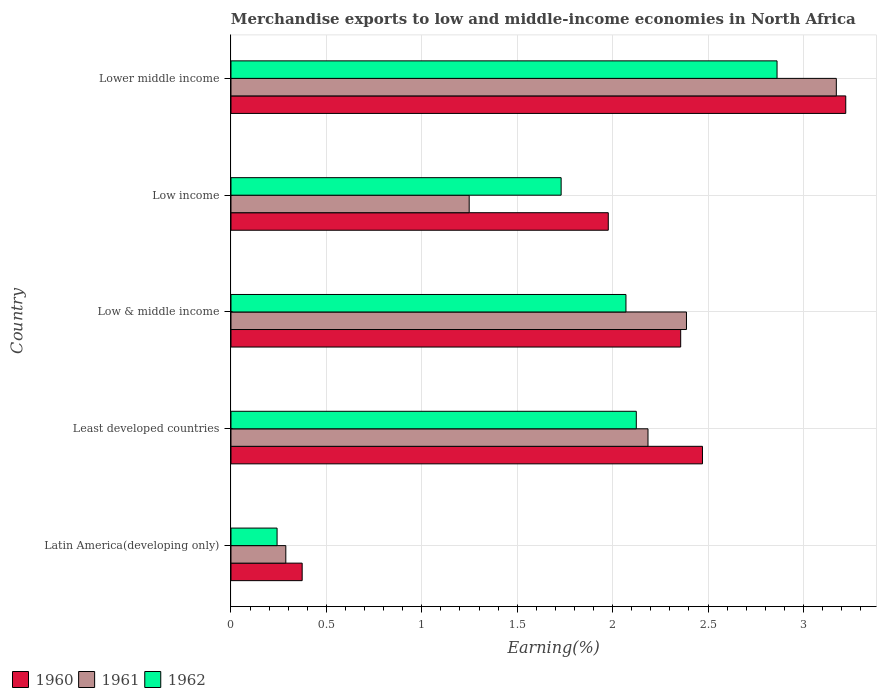Are the number of bars per tick equal to the number of legend labels?
Offer a terse response. Yes. Are the number of bars on each tick of the Y-axis equal?
Offer a terse response. Yes. How many bars are there on the 3rd tick from the top?
Give a very brief answer. 3. What is the label of the 4th group of bars from the top?
Ensure brevity in your answer.  Least developed countries. What is the percentage of amount earned from merchandise exports in 1960 in Low income?
Provide a succinct answer. 1.98. Across all countries, what is the maximum percentage of amount earned from merchandise exports in 1961?
Offer a very short reply. 3.17. Across all countries, what is the minimum percentage of amount earned from merchandise exports in 1962?
Provide a short and direct response. 0.24. In which country was the percentage of amount earned from merchandise exports in 1960 maximum?
Your answer should be compact. Lower middle income. In which country was the percentage of amount earned from merchandise exports in 1962 minimum?
Offer a terse response. Latin America(developing only). What is the total percentage of amount earned from merchandise exports in 1961 in the graph?
Provide a succinct answer. 9.28. What is the difference between the percentage of amount earned from merchandise exports in 1962 in Least developed countries and that in Lower middle income?
Offer a very short reply. -0.74. What is the difference between the percentage of amount earned from merchandise exports in 1962 in Latin America(developing only) and the percentage of amount earned from merchandise exports in 1960 in Low & middle income?
Give a very brief answer. -2.12. What is the average percentage of amount earned from merchandise exports in 1960 per country?
Ensure brevity in your answer.  2.08. What is the difference between the percentage of amount earned from merchandise exports in 1962 and percentage of amount earned from merchandise exports in 1961 in Latin America(developing only)?
Make the answer very short. -0.05. What is the ratio of the percentage of amount earned from merchandise exports in 1961 in Low & middle income to that in Low income?
Your answer should be compact. 1.91. Is the percentage of amount earned from merchandise exports in 1960 in Latin America(developing only) less than that in Low income?
Your answer should be very brief. Yes. What is the difference between the highest and the second highest percentage of amount earned from merchandise exports in 1960?
Offer a very short reply. 0.75. What is the difference between the highest and the lowest percentage of amount earned from merchandise exports in 1960?
Your answer should be compact. 2.85. In how many countries, is the percentage of amount earned from merchandise exports in 1962 greater than the average percentage of amount earned from merchandise exports in 1962 taken over all countries?
Give a very brief answer. 3. Is the sum of the percentage of amount earned from merchandise exports in 1960 in Low & middle income and Low income greater than the maximum percentage of amount earned from merchandise exports in 1962 across all countries?
Your answer should be very brief. Yes. What does the 1st bar from the top in Least developed countries represents?
Offer a very short reply. 1962. Is it the case that in every country, the sum of the percentage of amount earned from merchandise exports in 1960 and percentage of amount earned from merchandise exports in 1961 is greater than the percentage of amount earned from merchandise exports in 1962?
Make the answer very short. Yes. What is the difference between two consecutive major ticks on the X-axis?
Keep it short and to the point. 0.5. Are the values on the major ticks of X-axis written in scientific E-notation?
Provide a succinct answer. No. Does the graph contain grids?
Your answer should be compact. Yes. What is the title of the graph?
Give a very brief answer. Merchandise exports to low and middle-income economies in North Africa. What is the label or title of the X-axis?
Provide a succinct answer. Earning(%). What is the label or title of the Y-axis?
Offer a terse response. Country. What is the Earning(%) in 1960 in Latin America(developing only)?
Your response must be concise. 0.37. What is the Earning(%) in 1961 in Latin America(developing only)?
Your response must be concise. 0.29. What is the Earning(%) of 1962 in Latin America(developing only)?
Your response must be concise. 0.24. What is the Earning(%) of 1960 in Least developed countries?
Keep it short and to the point. 2.47. What is the Earning(%) in 1961 in Least developed countries?
Offer a terse response. 2.19. What is the Earning(%) of 1962 in Least developed countries?
Your response must be concise. 2.12. What is the Earning(%) of 1960 in Low & middle income?
Keep it short and to the point. 2.36. What is the Earning(%) in 1961 in Low & middle income?
Your answer should be very brief. 2.39. What is the Earning(%) of 1962 in Low & middle income?
Your response must be concise. 2.07. What is the Earning(%) of 1960 in Low income?
Your answer should be very brief. 1.98. What is the Earning(%) of 1961 in Low income?
Provide a succinct answer. 1.25. What is the Earning(%) of 1962 in Low income?
Provide a short and direct response. 1.73. What is the Earning(%) in 1960 in Lower middle income?
Your response must be concise. 3.22. What is the Earning(%) in 1961 in Lower middle income?
Provide a short and direct response. 3.17. What is the Earning(%) of 1962 in Lower middle income?
Make the answer very short. 2.86. Across all countries, what is the maximum Earning(%) in 1960?
Offer a terse response. 3.22. Across all countries, what is the maximum Earning(%) of 1961?
Make the answer very short. 3.17. Across all countries, what is the maximum Earning(%) in 1962?
Offer a very short reply. 2.86. Across all countries, what is the minimum Earning(%) of 1960?
Provide a succinct answer. 0.37. Across all countries, what is the minimum Earning(%) of 1961?
Ensure brevity in your answer.  0.29. Across all countries, what is the minimum Earning(%) in 1962?
Make the answer very short. 0.24. What is the total Earning(%) in 1960 in the graph?
Provide a succinct answer. 10.4. What is the total Earning(%) of 1961 in the graph?
Your response must be concise. 9.28. What is the total Earning(%) of 1962 in the graph?
Your response must be concise. 9.03. What is the difference between the Earning(%) of 1960 in Latin America(developing only) and that in Least developed countries?
Your response must be concise. -2.1. What is the difference between the Earning(%) in 1961 in Latin America(developing only) and that in Least developed countries?
Offer a very short reply. -1.9. What is the difference between the Earning(%) in 1962 in Latin America(developing only) and that in Least developed countries?
Your response must be concise. -1.88. What is the difference between the Earning(%) in 1960 in Latin America(developing only) and that in Low & middle income?
Make the answer very short. -1.98. What is the difference between the Earning(%) of 1961 in Latin America(developing only) and that in Low & middle income?
Make the answer very short. -2.1. What is the difference between the Earning(%) of 1962 in Latin America(developing only) and that in Low & middle income?
Give a very brief answer. -1.83. What is the difference between the Earning(%) of 1960 in Latin America(developing only) and that in Low income?
Offer a terse response. -1.6. What is the difference between the Earning(%) in 1961 in Latin America(developing only) and that in Low income?
Ensure brevity in your answer.  -0.96. What is the difference between the Earning(%) of 1962 in Latin America(developing only) and that in Low income?
Offer a very short reply. -1.49. What is the difference between the Earning(%) of 1960 in Latin America(developing only) and that in Lower middle income?
Offer a terse response. -2.85. What is the difference between the Earning(%) in 1961 in Latin America(developing only) and that in Lower middle income?
Ensure brevity in your answer.  -2.88. What is the difference between the Earning(%) of 1962 in Latin America(developing only) and that in Lower middle income?
Your answer should be compact. -2.62. What is the difference between the Earning(%) of 1960 in Least developed countries and that in Low & middle income?
Your answer should be compact. 0.11. What is the difference between the Earning(%) of 1961 in Least developed countries and that in Low & middle income?
Make the answer very short. -0.2. What is the difference between the Earning(%) in 1962 in Least developed countries and that in Low & middle income?
Provide a succinct answer. 0.05. What is the difference between the Earning(%) of 1960 in Least developed countries and that in Low income?
Your response must be concise. 0.49. What is the difference between the Earning(%) of 1961 in Least developed countries and that in Low income?
Keep it short and to the point. 0.94. What is the difference between the Earning(%) of 1962 in Least developed countries and that in Low income?
Keep it short and to the point. 0.39. What is the difference between the Earning(%) in 1960 in Least developed countries and that in Lower middle income?
Your answer should be compact. -0.75. What is the difference between the Earning(%) in 1961 in Least developed countries and that in Lower middle income?
Offer a terse response. -0.99. What is the difference between the Earning(%) in 1962 in Least developed countries and that in Lower middle income?
Offer a terse response. -0.74. What is the difference between the Earning(%) of 1960 in Low & middle income and that in Low income?
Provide a short and direct response. 0.38. What is the difference between the Earning(%) in 1961 in Low & middle income and that in Low income?
Make the answer very short. 1.14. What is the difference between the Earning(%) in 1962 in Low & middle income and that in Low income?
Make the answer very short. 0.34. What is the difference between the Earning(%) in 1960 in Low & middle income and that in Lower middle income?
Keep it short and to the point. -0.86. What is the difference between the Earning(%) of 1961 in Low & middle income and that in Lower middle income?
Make the answer very short. -0.79. What is the difference between the Earning(%) in 1962 in Low & middle income and that in Lower middle income?
Your answer should be compact. -0.79. What is the difference between the Earning(%) of 1960 in Low income and that in Lower middle income?
Offer a very short reply. -1.24. What is the difference between the Earning(%) in 1961 in Low income and that in Lower middle income?
Offer a very short reply. -1.92. What is the difference between the Earning(%) in 1962 in Low income and that in Lower middle income?
Offer a very short reply. -1.13. What is the difference between the Earning(%) of 1960 in Latin America(developing only) and the Earning(%) of 1961 in Least developed countries?
Ensure brevity in your answer.  -1.81. What is the difference between the Earning(%) of 1960 in Latin America(developing only) and the Earning(%) of 1962 in Least developed countries?
Provide a short and direct response. -1.75. What is the difference between the Earning(%) of 1961 in Latin America(developing only) and the Earning(%) of 1962 in Least developed countries?
Provide a succinct answer. -1.84. What is the difference between the Earning(%) in 1960 in Latin America(developing only) and the Earning(%) in 1961 in Low & middle income?
Offer a terse response. -2.01. What is the difference between the Earning(%) of 1960 in Latin America(developing only) and the Earning(%) of 1962 in Low & middle income?
Offer a terse response. -1.7. What is the difference between the Earning(%) in 1961 in Latin America(developing only) and the Earning(%) in 1962 in Low & middle income?
Give a very brief answer. -1.78. What is the difference between the Earning(%) in 1960 in Latin America(developing only) and the Earning(%) in 1961 in Low income?
Keep it short and to the point. -0.88. What is the difference between the Earning(%) of 1960 in Latin America(developing only) and the Earning(%) of 1962 in Low income?
Your response must be concise. -1.36. What is the difference between the Earning(%) in 1961 in Latin America(developing only) and the Earning(%) in 1962 in Low income?
Offer a terse response. -1.44. What is the difference between the Earning(%) of 1960 in Latin America(developing only) and the Earning(%) of 1961 in Lower middle income?
Keep it short and to the point. -2.8. What is the difference between the Earning(%) in 1960 in Latin America(developing only) and the Earning(%) in 1962 in Lower middle income?
Your answer should be very brief. -2.49. What is the difference between the Earning(%) of 1961 in Latin America(developing only) and the Earning(%) of 1962 in Lower middle income?
Your answer should be compact. -2.57. What is the difference between the Earning(%) of 1960 in Least developed countries and the Earning(%) of 1961 in Low & middle income?
Provide a short and direct response. 0.08. What is the difference between the Earning(%) of 1960 in Least developed countries and the Earning(%) of 1962 in Low & middle income?
Offer a terse response. 0.4. What is the difference between the Earning(%) of 1961 in Least developed countries and the Earning(%) of 1962 in Low & middle income?
Your response must be concise. 0.12. What is the difference between the Earning(%) of 1960 in Least developed countries and the Earning(%) of 1961 in Low income?
Provide a succinct answer. 1.22. What is the difference between the Earning(%) in 1960 in Least developed countries and the Earning(%) in 1962 in Low income?
Give a very brief answer. 0.74. What is the difference between the Earning(%) of 1961 in Least developed countries and the Earning(%) of 1962 in Low income?
Provide a short and direct response. 0.46. What is the difference between the Earning(%) in 1960 in Least developed countries and the Earning(%) in 1961 in Lower middle income?
Offer a terse response. -0.7. What is the difference between the Earning(%) of 1960 in Least developed countries and the Earning(%) of 1962 in Lower middle income?
Give a very brief answer. -0.39. What is the difference between the Earning(%) of 1961 in Least developed countries and the Earning(%) of 1962 in Lower middle income?
Your response must be concise. -0.68. What is the difference between the Earning(%) of 1960 in Low & middle income and the Earning(%) of 1961 in Low income?
Your response must be concise. 1.11. What is the difference between the Earning(%) of 1960 in Low & middle income and the Earning(%) of 1962 in Low income?
Your answer should be compact. 0.63. What is the difference between the Earning(%) in 1961 in Low & middle income and the Earning(%) in 1962 in Low income?
Your answer should be very brief. 0.66. What is the difference between the Earning(%) of 1960 in Low & middle income and the Earning(%) of 1961 in Lower middle income?
Keep it short and to the point. -0.82. What is the difference between the Earning(%) of 1960 in Low & middle income and the Earning(%) of 1962 in Lower middle income?
Offer a terse response. -0.5. What is the difference between the Earning(%) in 1961 in Low & middle income and the Earning(%) in 1962 in Lower middle income?
Provide a succinct answer. -0.47. What is the difference between the Earning(%) in 1960 in Low income and the Earning(%) in 1961 in Lower middle income?
Ensure brevity in your answer.  -1.2. What is the difference between the Earning(%) of 1960 in Low income and the Earning(%) of 1962 in Lower middle income?
Give a very brief answer. -0.88. What is the difference between the Earning(%) of 1961 in Low income and the Earning(%) of 1962 in Lower middle income?
Give a very brief answer. -1.61. What is the average Earning(%) of 1960 per country?
Provide a succinct answer. 2.08. What is the average Earning(%) of 1961 per country?
Make the answer very short. 1.86. What is the average Earning(%) in 1962 per country?
Offer a terse response. 1.81. What is the difference between the Earning(%) of 1960 and Earning(%) of 1961 in Latin America(developing only)?
Keep it short and to the point. 0.09. What is the difference between the Earning(%) of 1960 and Earning(%) of 1962 in Latin America(developing only)?
Offer a very short reply. 0.13. What is the difference between the Earning(%) in 1961 and Earning(%) in 1962 in Latin America(developing only)?
Your answer should be very brief. 0.05. What is the difference between the Earning(%) of 1960 and Earning(%) of 1961 in Least developed countries?
Provide a succinct answer. 0.29. What is the difference between the Earning(%) of 1960 and Earning(%) of 1962 in Least developed countries?
Ensure brevity in your answer.  0.35. What is the difference between the Earning(%) in 1961 and Earning(%) in 1962 in Least developed countries?
Your answer should be very brief. 0.06. What is the difference between the Earning(%) in 1960 and Earning(%) in 1961 in Low & middle income?
Offer a terse response. -0.03. What is the difference between the Earning(%) in 1960 and Earning(%) in 1962 in Low & middle income?
Keep it short and to the point. 0.29. What is the difference between the Earning(%) of 1961 and Earning(%) of 1962 in Low & middle income?
Keep it short and to the point. 0.32. What is the difference between the Earning(%) of 1960 and Earning(%) of 1961 in Low income?
Give a very brief answer. 0.73. What is the difference between the Earning(%) in 1960 and Earning(%) in 1962 in Low income?
Your answer should be very brief. 0.25. What is the difference between the Earning(%) in 1961 and Earning(%) in 1962 in Low income?
Your response must be concise. -0.48. What is the difference between the Earning(%) in 1960 and Earning(%) in 1961 in Lower middle income?
Your answer should be very brief. 0.05. What is the difference between the Earning(%) of 1960 and Earning(%) of 1962 in Lower middle income?
Offer a terse response. 0.36. What is the difference between the Earning(%) of 1961 and Earning(%) of 1962 in Lower middle income?
Provide a short and direct response. 0.31. What is the ratio of the Earning(%) of 1960 in Latin America(developing only) to that in Least developed countries?
Your answer should be very brief. 0.15. What is the ratio of the Earning(%) of 1961 in Latin America(developing only) to that in Least developed countries?
Your response must be concise. 0.13. What is the ratio of the Earning(%) in 1962 in Latin America(developing only) to that in Least developed countries?
Offer a very short reply. 0.11. What is the ratio of the Earning(%) of 1960 in Latin America(developing only) to that in Low & middle income?
Your answer should be very brief. 0.16. What is the ratio of the Earning(%) of 1961 in Latin America(developing only) to that in Low & middle income?
Make the answer very short. 0.12. What is the ratio of the Earning(%) of 1962 in Latin America(developing only) to that in Low & middle income?
Your answer should be very brief. 0.12. What is the ratio of the Earning(%) in 1960 in Latin America(developing only) to that in Low income?
Offer a terse response. 0.19. What is the ratio of the Earning(%) of 1961 in Latin America(developing only) to that in Low income?
Make the answer very short. 0.23. What is the ratio of the Earning(%) of 1962 in Latin America(developing only) to that in Low income?
Give a very brief answer. 0.14. What is the ratio of the Earning(%) in 1960 in Latin America(developing only) to that in Lower middle income?
Provide a short and direct response. 0.12. What is the ratio of the Earning(%) in 1961 in Latin America(developing only) to that in Lower middle income?
Keep it short and to the point. 0.09. What is the ratio of the Earning(%) of 1962 in Latin America(developing only) to that in Lower middle income?
Give a very brief answer. 0.08. What is the ratio of the Earning(%) in 1960 in Least developed countries to that in Low & middle income?
Offer a very short reply. 1.05. What is the ratio of the Earning(%) of 1961 in Least developed countries to that in Low & middle income?
Provide a short and direct response. 0.92. What is the ratio of the Earning(%) of 1962 in Least developed countries to that in Low & middle income?
Give a very brief answer. 1.03. What is the ratio of the Earning(%) of 1960 in Least developed countries to that in Low income?
Provide a short and direct response. 1.25. What is the ratio of the Earning(%) in 1961 in Least developed countries to that in Low income?
Your response must be concise. 1.75. What is the ratio of the Earning(%) in 1962 in Least developed countries to that in Low income?
Make the answer very short. 1.23. What is the ratio of the Earning(%) of 1960 in Least developed countries to that in Lower middle income?
Your answer should be compact. 0.77. What is the ratio of the Earning(%) in 1961 in Least developed countries to that in Lower middle income?
Ensure brevity in your answer.  0.69. What is the ratio of the Earning(%) in 1962 in Least developed countries to that in Lower middle income?
Provide a succinct answer. 0.74. What is the ratio of the Earning(%) in 1960 in Low & middle income to that in Low income?
Provide a succinct answer. 1.19. What is the ratio of the Earning(%) in 1961 in Low & middle income to that in Low income?
Your answer should be compact. 1.91. What is the ratio of the Earning(%) in 1962 in Low & middle income to that in Low income?
Provide a succinct answer. 1.2. What is the ratio of the Earning(%) of 1960 in Low & middle income to that in Lower middle income?
Provide a short and direct response. 0.73. What is the ratio of the Earning(%) of 1961 in Low & middle income to that in Lower middle income?
Offer a very short reply. 0.75. What is the ratio of the Earning(%) of 1962 in Low & middle income to that in Lower middle income?
Make the answer very short. 0.72. What is the ratio of the Earning(%) of 1960 in Low income to that in Lower middle income?
Ensure brevity in your answer.  0.61. What is the ratio of the Earning(%) in 1961 in Low income to that in Lower middle income?
Offer a terse response. 0.39. What is the ratio of the Earning(%) in 1962 in Low income to that in Lower middle income?
Ensure brevity in your answer.  0.6. What is the difference between the highest and the second highest Earning(%) in 1960?
Your answer should be very brief. 0.75. What is the difference between the highest and the second highest Earning(%) of 1961?
Your answer should be very brief. 0.79. What is the difference between the highest and the second highest Earning(%) of 1962?
Offer a very short reply. 0.74. What is the difference between the highest and the lowest Earning(%) in 1960?
Your answer should be compact. 2.85. What is the difference between the highest and the lowest Earning(%) of 1961?
Make the answer very short. 2.88. What is the difference between the highest and the lowest Earning(%) of 1962?
Your response must be concise. 2.62. 